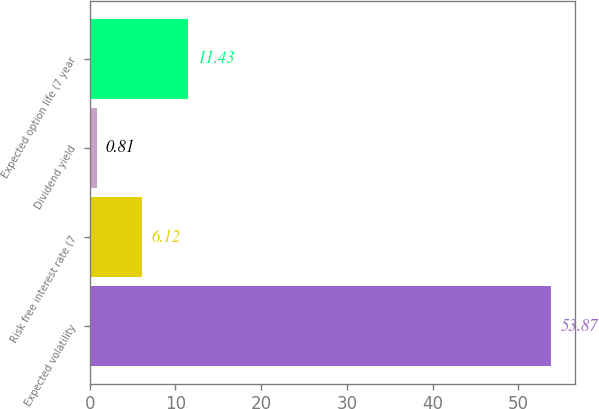<chart> <loc_0><loc_0><loc_500><loc_500><bar_chart><fcel>Expected volatility<fcel>Risk free interest rate (7<fcel>Dividend yield<fcel>Expected option life (7 year<nl><fcel>53.87<fcel>6.12<fcel>0.81<fcel>11.43<nl></chart> 